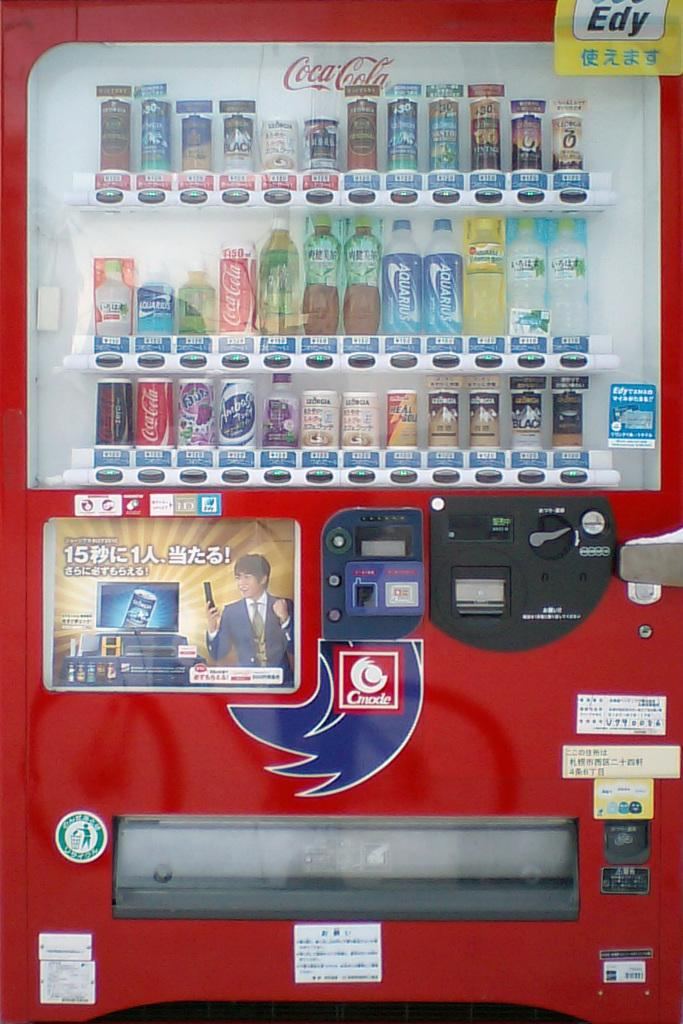Provide a one-sentence caption for the provided image. A red vending machine selling Coca-Cola products and Chinese labeled drinks. 